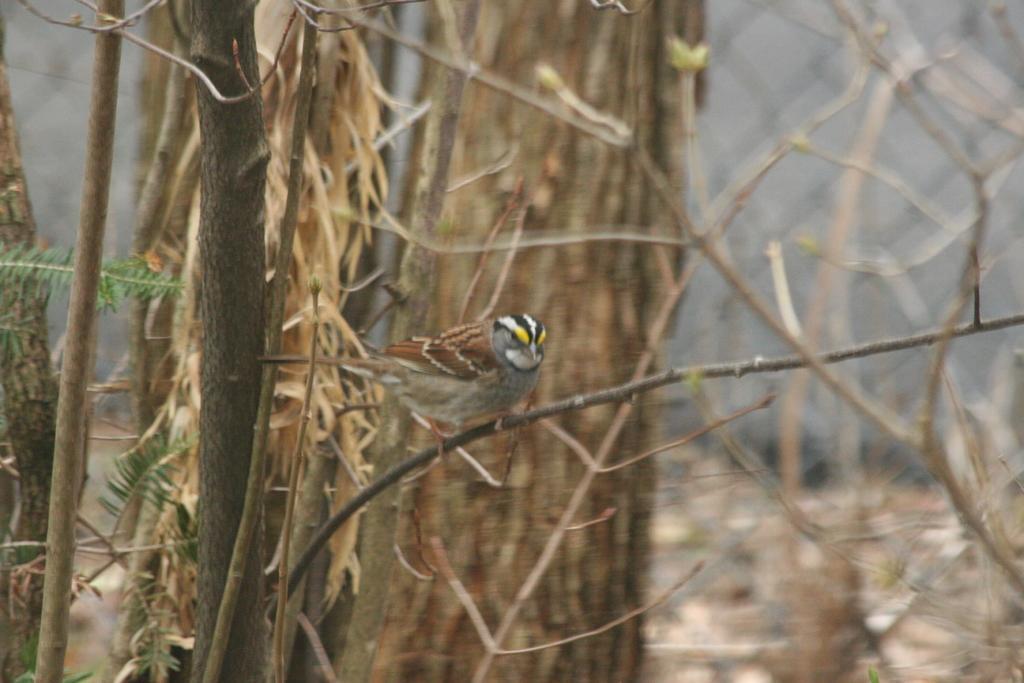Describe this image in one or two sentences. This picture is clicked outside. In the center there is a bird standing on the stem of a tree. In the background we can see the trunks of the trees and the dried stems. On the left we can see the leaves. 